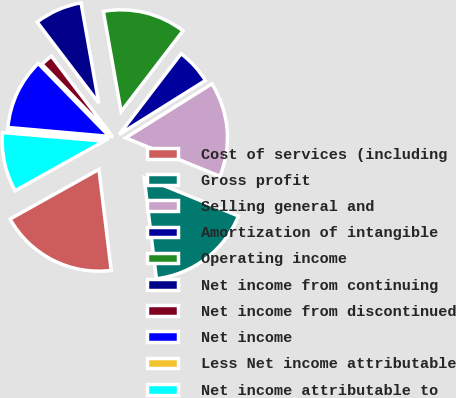Convert chart to OTSL. <chart><loc_0><loc_0><loc_500><loc_500><pie_chart><fcel>Cost of services (including<fcel>Gross profit<fcel>Selling general and<fcel>Amortization of intangible<fcel>Operating income<fcel>Net income from continuing<fcel>Net income from discontinued<fcel>Net income<fcel>Less Net income attributable<fcel>Net income attributable to<nl><fcel>18.81%<fcel>16.93%<fcel>15.06%<fcel>5.69%<fcel>13.19%<fcel>7.56%<fcel>1.94%<fcel>11.31%<fcel>0.07%<fcel>9.44%<nl></chart> 